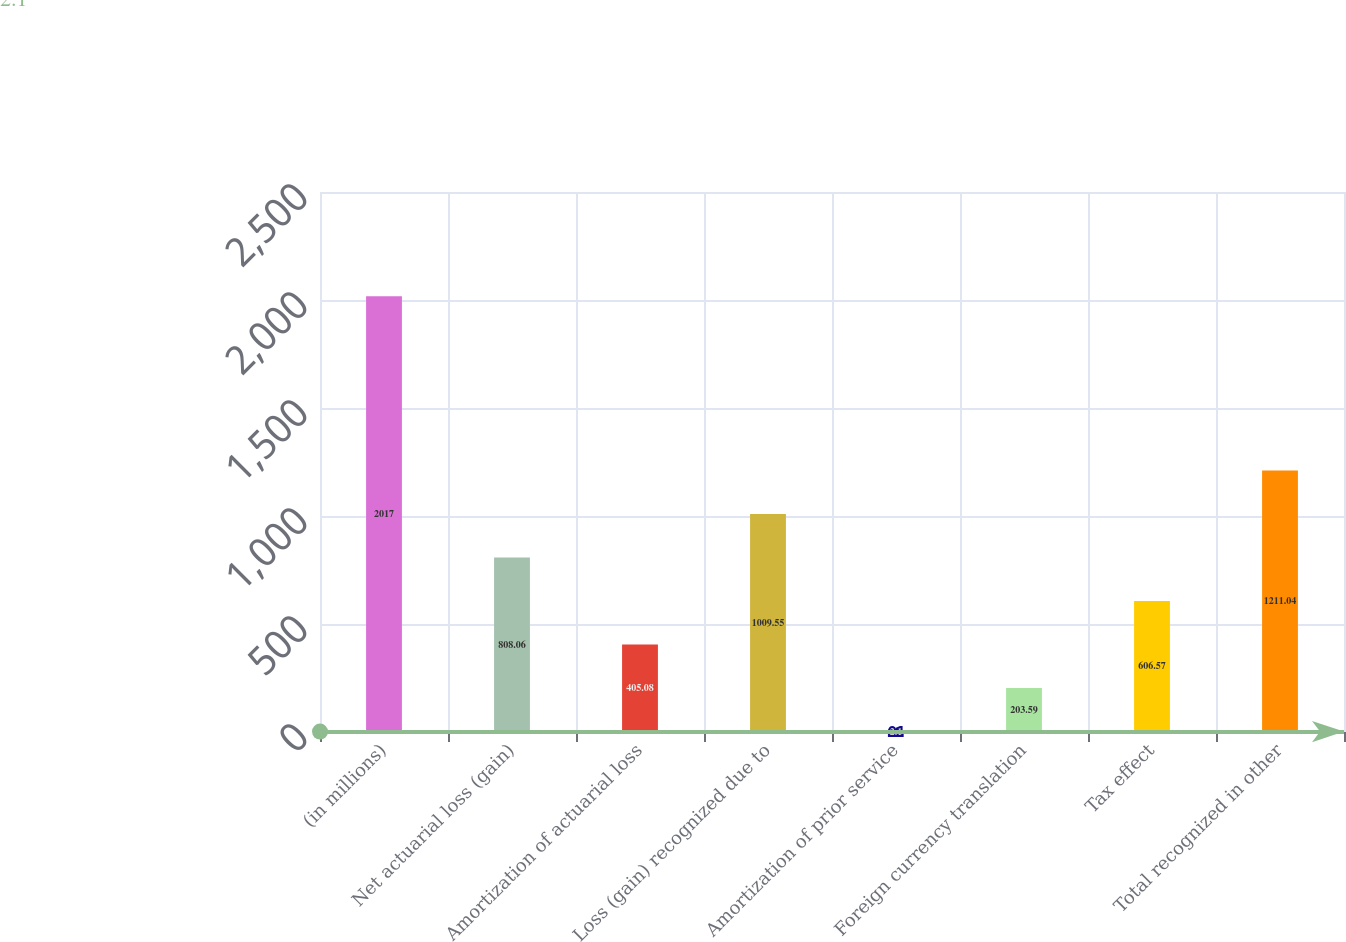Convert chart to OTSL. <chart><loc_0><loc_0><loc_500><loc_500><bar_chart><fcel>(in millions)<fcel>Net actuarial loss (gain)<fcel>Amortization of actuarial loss<fcel>Loss (gain) recognized due to<fcel>Amortization of prior service<fcel>Foreign currency translation<fcel>Tax effect<fcel>Total recognized in other<nl><fcel>2017<fcel>808.06<fcel>405.08<fcel>1009.55<fcel>2.1<fcel>203.59<fcel>606.57<fcel>1211.04<nl></chart> 